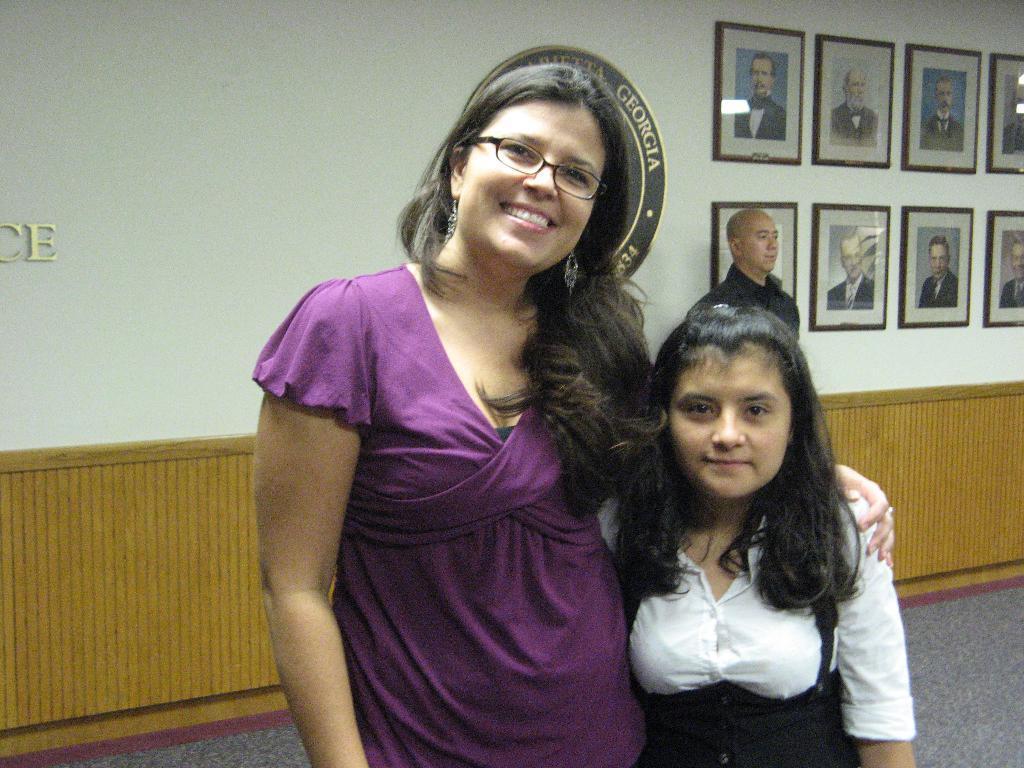How would you summarize this image in a sentence or two? In this picture there is a lady and a girl in the center of the image and there is a man behind them, there are photographs on the wall in the background area of the image. 